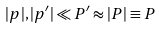<formula> <loc_0><loc_0><loc_500><loc_500>| { p } | , | { p } ^ { \prime } | \ll P ^ { \prime } \approx | { P } | \equiv P</formula> 